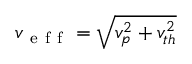<formula> <loc_0><loc_0><loc_500><loc_500>v _ { e f f } = \sqrt { v _ { p } ^ { 2 } + v _ { t h } ^ { 2 } }</formula> 